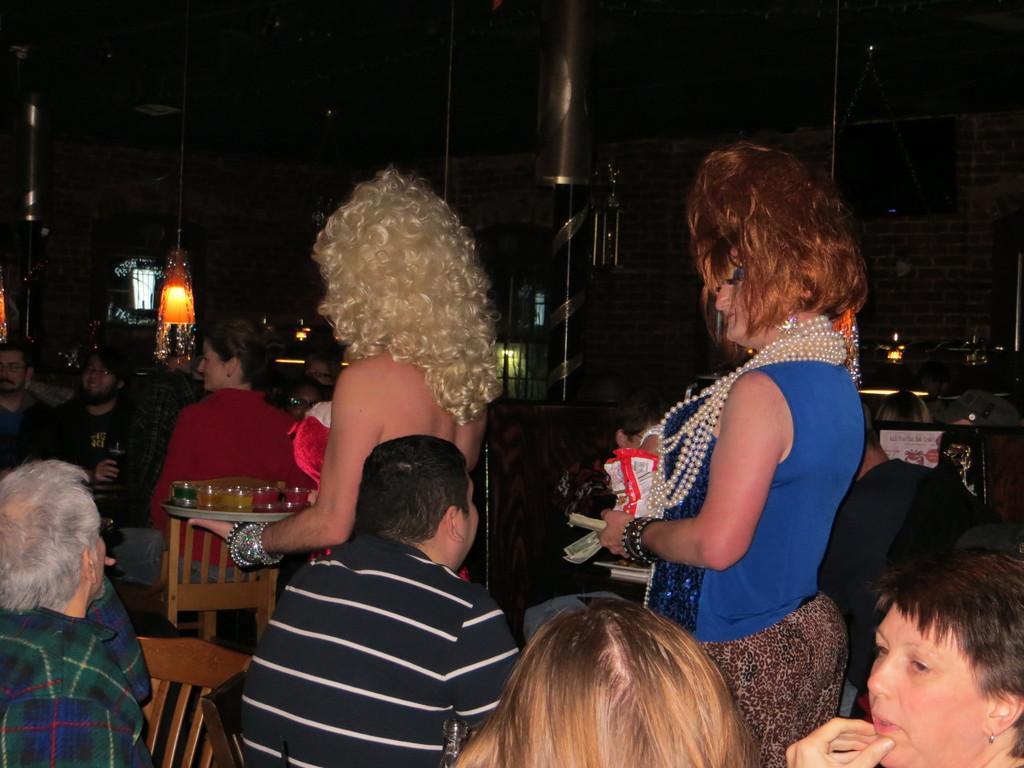Could you give a brief overview of what you see in this image? In this image there are two women standing, they are holding an object, there are a group of persons sitting on the chairs, there is a wall towards the right of the image, there are lights, there is an object towards the top of the image, there is roof towards the top of the image, there is an object towards the left of the image, the background of the image is dark. 